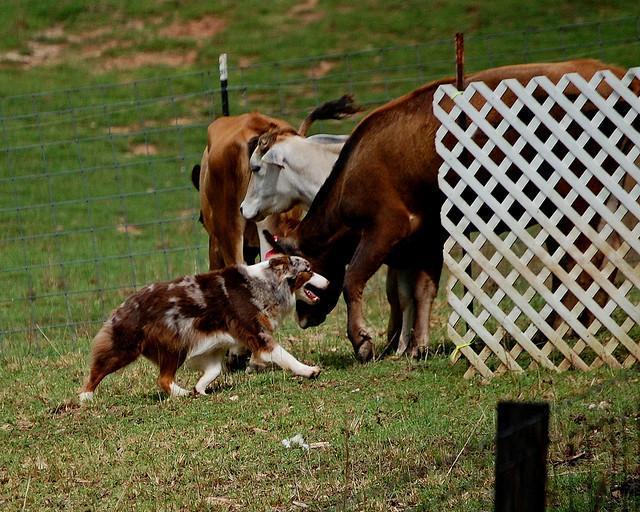How many cows are visible?
Give a very brief answer. 3. How many dogs are there?
Give a very brief answer. 1. How many people are on the elephant on the right?
Give a very brief answer. 0. 